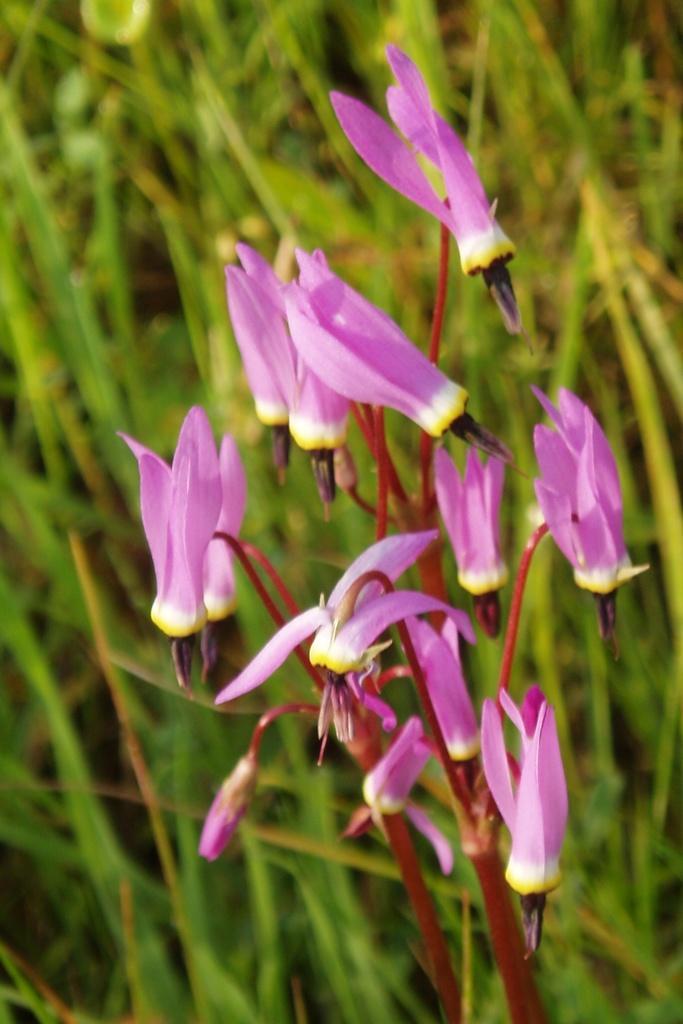In one or two sentences, can you explain what this image depicts? There is a plant and there are pink color flowers to the plant. 